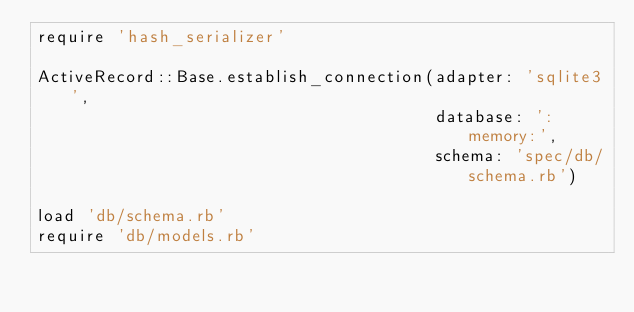Convert code to text. <code><loc_0><loc_0><loc_500><loc_500><_Ruby_>require 'hash_serializer'

ActiveRecord::Base.establish_connection(adapter: 'sqlite3',
                                        database: ':memory:',
                                        schema: 'spec/db/schema.rb')

load 'db/schema.rb'
require 'db/models.rb'
</code> 